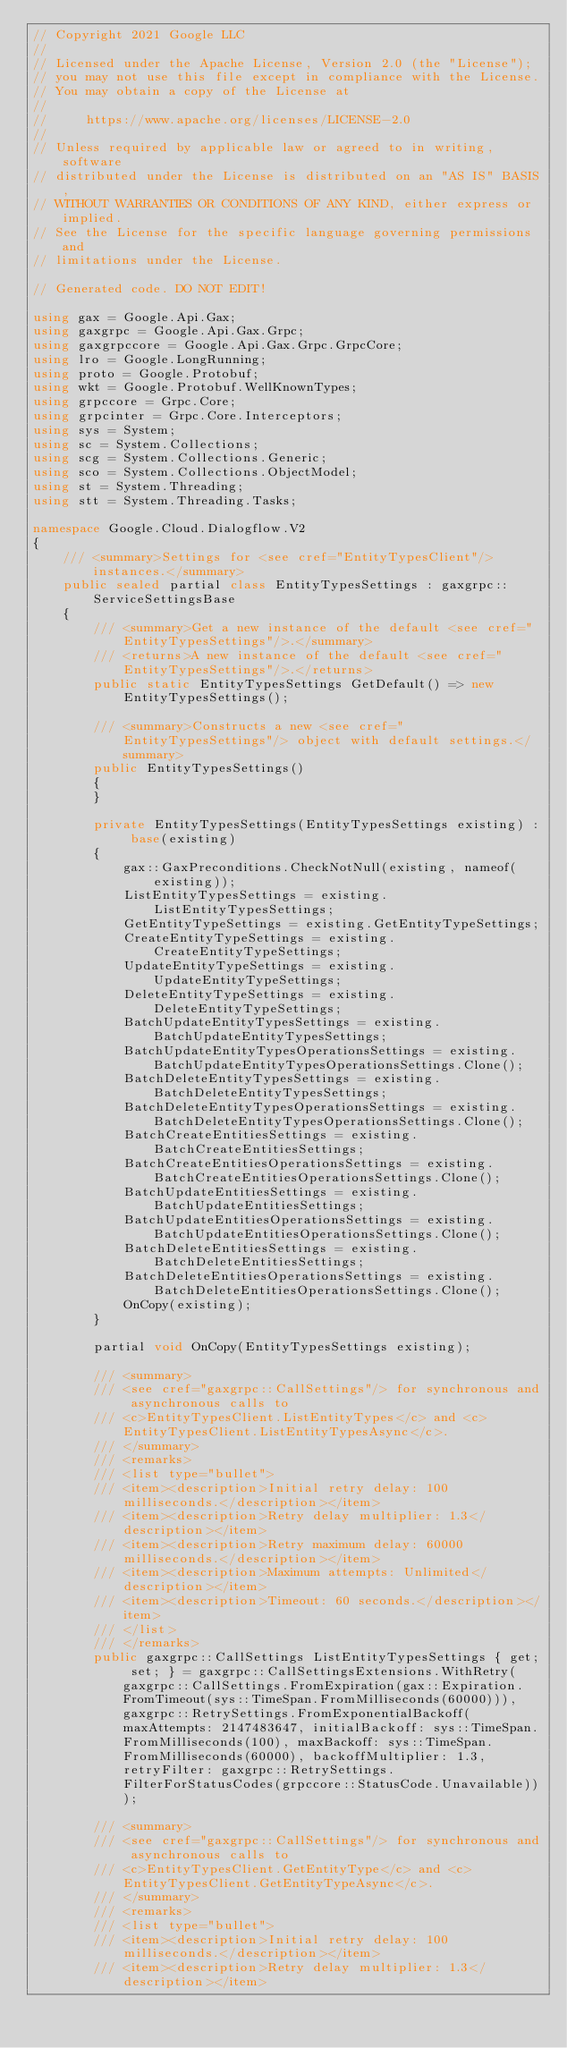Convert code to text. <code><loc_0><loc_0><loc_500><loc_500><_C#_>// Copyright 2021 Google LLC
//
// Licensed under the Apache License, Version 2.0 (the "License");
// you may not use this file except in compliance with the License.
// You may obtain a copy of the License at
//
//     https://www.apache.org/licenses/LICENSE-2.0
//
// Unless required by applicable law or agreed to in writing, software
// distributed under the License is distributed on an "AS IS" BASIS,
// WITHOUT WARRANTIES OR CONDITIONS OF ANY KIND, either express or implied.
// See the License for the specific language governing permissions and
// limitations under the License.

// Generated code. DO NOT EDIT!

using gax = Google.Api.Gax;
using gaxgrpc = Google.Api.Gax.Grpc;
using gaxgrpccore = Google.Api.Gax.Grpc.GrpcCore;
using lro = Google.LongRunning;
using proto = Google.Protobuf;
using wkt = Google.Protobuf.WellKnownTypes;
using grpccore = Grpc.Core;
using grpcinter = Grpc.Core.Interceptors;
using sys = System;
using sc = System.Collections;
using scg = System.Collections.Generic;
using sco = System.Collections.ObjectModel;
using st = System.Threading;
using stt = System.Threading.Tasks;

namespace Google.Cloud.Dialogflow.V2
{
    /// <summary>Settings for <see cref="EntityTypesClient"/> instances.</summary>
    public sealed partial class EntityTypesSettings : gaxgrpc::ServiceSettingsBase
    {
        /// <summary>Get a new instance of the default <see cref="EntityTypesSettings"/>.</summary>
        /// <returns>A new instance of the default <see cref="EntityTypesSettings"/>.</returns>
        public static EntityTypesSettings GetDefault() => new EntityTypesSettings();

        /// <summary>Constructs a new <see cref="EntityTypesSettings"/> object with default settings.</summary>
        public EntityTypesSettings()
        {
        }

        private EntityTypesSettings(EntityTypesSettings existing) : base(existing)
        {
            gax::GaxPreconditions.CheckNotNull(existing, nameof(existing));
            ListEntityTypesSettings = existing.ListEntityTypesSettings;
            GetEntityTypeSettings = existing.GetEntityTypeSettings;
            CreateEntityTypeSettings = existing.CreateEntityTypeSettings;
            UpdateEntityTypeSettings = existing.UpdateEntityTypeSettings;
            DeleteEntityTypeSettings = existing.DeleteEntityTypeSettings;
            BatchUpdateEntityTypesSettings = existing.BatchUpdateEntityTypesSettings;
            BatchUpdateEntityTypesOperationsSettings = existing.BatchUpdateEntityTypesOperationsSettings.Clone();
            BatchDeleteEntityTypesSettings = existing.BatchDeleteEntityTypesSettings;
            BatchDeleteEntityTypesOperationsSettings = existing.BatchDeleteEntityTypesOperationsSettings.Clone();
            BatchCreateEntitiesSettings = existing.BatchCreateEntitiesSettings;
            BatchCreateEntitiesOperationsSettings = existing.BatchCreateEntitiesOperationsSettings.Clone();
            BatchUpdateEntitiesSettings = existing.BatchUpdateEntitiesSettings;
            BatchUpdateEntitiesOperationsSettings = existing.BatchUpdateEntitiesOperationsSettings.Clone();
            BatchDeleteEntitiesSettings = existing.BatchDeleteEntitiesSettings;
            BatchDeleteEntitiesOperationsSettings = existing.BatchDeleteEntitiesOperationsSettings.Clone();
            OnCopy(existing);
        }

        partial void OnCopy(EntityTypesSettings existing);

        /// <summary>
        /// <see cref="gaxgrpc::CallSettings"/> for synchronous and asynchronous calls to
        /// <c>EntityTypesClient.ListEntityTypes</c> and <c>EntityTypesClient.ListEntityTypesAsync</c>.
        /// </summary>
        /// <remarks>
        /// <list type="bullet">
        /// <item><description>Initial retry delay: 100 milliseconds.</description></item>
        /// <item><description>Retry delay multiplier: 1.3</description></item>
        /// <item><description>Retry maximum delay: 60000 milliseconds.</description></item>
        /// <item><description>Maximum attempts: Unlimited</description></item>
        /// <item><description>Timeout: 60 seconds.</description></item>
        /// </list>
        /// </remarks>
        public gaxgrpc::CallSettings ListEntityTypesSettings { get; set; } = gaxgrpc::CallSettingsExtensions.WithRetry(gaxgrpc::CallSettings.FromExpiration(gax::Expiration.FromTimeout(sys::TimeSpan.FromMilliseconds(60000))), gaxgrpc::RetrySettings.FromExponentialBackoff(maxAttempts: 2147483647, initialBackoff: sys::TimeSpan.FromMilliseconds(100), maxBackoff: sys::TimeSpan.FromMilliseconds(60000), backoffMultiplier: 1.3, retryFilter: gaxgrpc::RetrySettings.FilterForStatusCodes(grpccore::StatusCode.Unavailable)));

        /// <summary>
        /// <see cref="gaxgrpc::CallSettings"/> for synchronous and asynchronous calls to
        /// <c>EntityTypesClient.GetEntityType</c> and <c>EntityTypesClient.GetEntityTypeAsync</c>.
        /// </summary>
        /// <remarks>
        /// <list type="bullet">
        /// <item><description>Initial retry delay: 100 milliseconds.</description></item>
        /// <item><description>Retry delay multiplier: 1.3</description></item></code> 